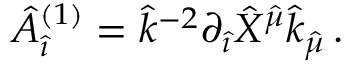Convert formula to latex. <formula><loc_0><loc_0><loc_500><loc_500>{ \hat { A } } _ { \hat { \imath } } ^ { ( 1 ) } = { \hat { k } } ^ { - 2 } \partial _ { \hat { \imath } } { \hat { X } } ^ { { \hat { \mu } } } { \hat { k } } _ { \hat { \mu } } \, .</formula> 